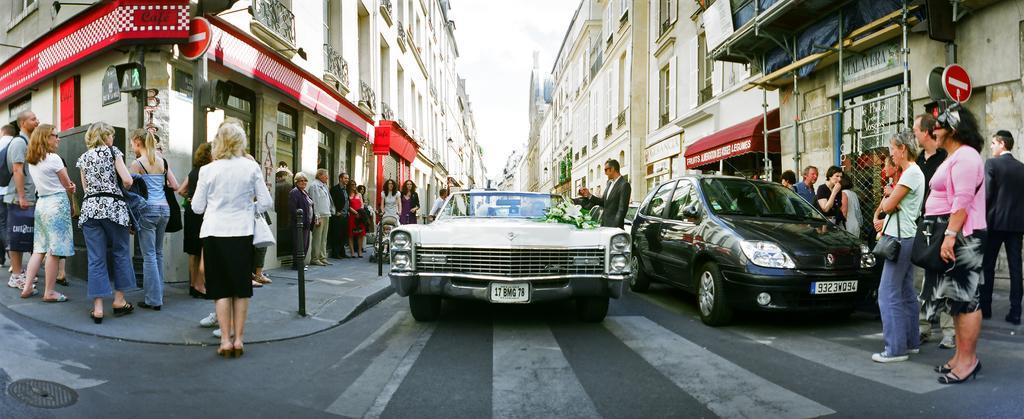Could you give a brief overview of what you see in this image? In this image, we can see vehicles on the road and in the background, there are many people standing and some are wearing bags and we can see stands, buildings and sign boards. At the top, there is sky. 